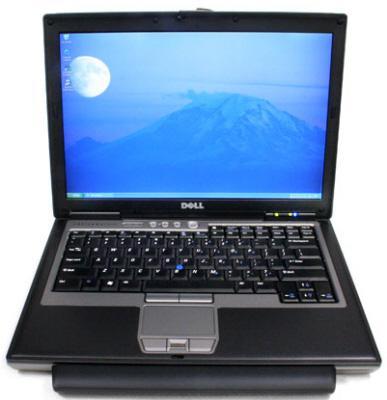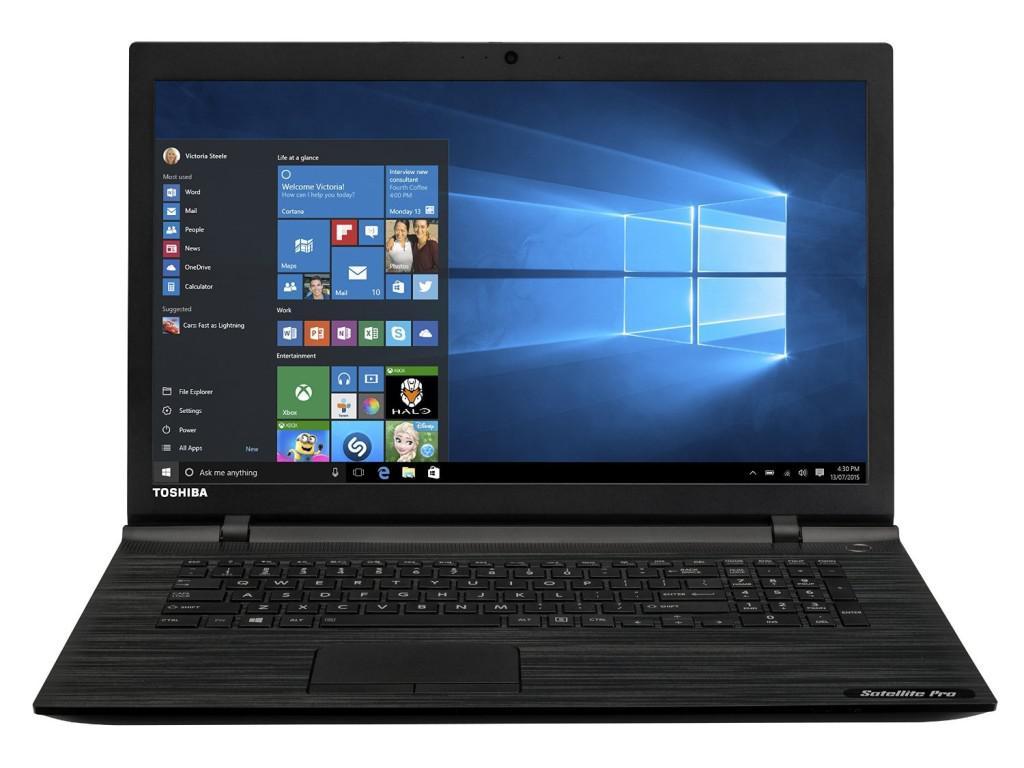The first image is the image on the left, the second image is the image on the right. For the images displayed, is the sentence "The laptop on the right has its start menu open and visible." factually correct? Answer yes or no. Yes. The first image is the image on the left, the second image is the image on the right. Considering the images on both sides, is "At least one laptop shows the Windows menu." valid? Answer yes or no. Yes. 